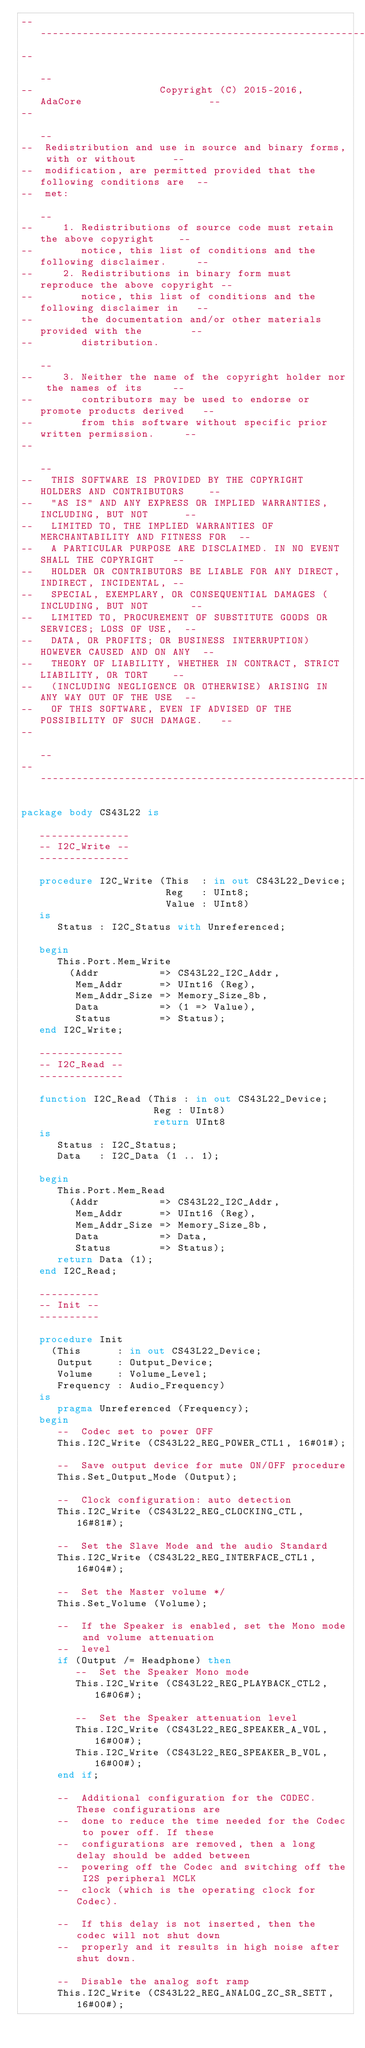<code> <loc_0><loc_0><loc_500><loc_500><_Ada_>------------------------------------------------------------------------------
--                                                                          --
--                     Copyright (C) 2015-2016, AdaCore                     --
--                                                                          --
--  Redistribution and use in source and binary forms, with or without      --
--  modification, are permitted provided that the following conditions are  --
--  met:                                                                    --
--     1. Redistributions of source code must retain the above copyright    --
--        notice, this list of conditions and the following disclaimer.     --
--     2. Redistributions in binary form must reproduce the above copyright --
--        notice, this list of conditions and the following disclaimer in   --
--        the documentation and/or other materials provided with the        --
--        distribution.                                                     --
--     3. Neither the name of the copyright holder nor the names of its     --
--        contributors may be used to endorse or promote products derived   --
--        from this software without specific prior written permission.     --
--                                                                          --
--   THIS SOFTWARE IS PROVIDED BY THE COPYRIGHT HOLDERS AND CONTRIBUTORS    --
--   "AS IS" AND ANY EXPRESS OR IMPLIED WARRANTIES, INCLUDING, BUT NOT      --
--   LIMITED TO, THE IMPLIED WARRANTIES OF MERCHANTABILITY AND FITNESS FOR  --
--   A PARTICULAR PURPOSE ARE DISCLAIMED. IN NO EVENT SHALL THE COPYRIGHT   --
--   HOLDER OR CONTRIBUTORS BE LIABLE FOR ANY DIRECT, INDIRECT, INCIDENTAL, --
--   SPECIAL, EXEMPLARY, OR CONSEQUENTIAL DAMAGES (INCLUDING, BUT NOT       --
--   LIMITED TO, PROCUREMENT OF SUBSTITUTE GOODS OR SERVICES; LOSS OF USE,  --
--   DATA, OR PROFITS; OR BUSINESS INTERRUPTION) HOWEVER CAUSED AND ON ANY  --
--   THEORY OF LIABILITY, WHETHER IN CONTRACT, STRICT LIABILITY, OR TORT    --
--   (INCLUDING NEGLIGENCE OR OTHERWISE) ARISING IN ANY WAY OUT OF THE USE  --
--   OF THIS SOFTWARE, EVEN IF ADVISED OF THE POSSIBILITY OF SUCH DAMAGE.   --
--                                                                          --
------------------------------------------------------------------------------

package body CS43L22 is

   ---------------
   -- I2C_Write --
   ---------------

   procedure I2C_Write (This  : in out CS43L22_Device;
                        Reg   : UInt8;
                        Value : UInt8)
   is
      Status : I2C_Status with Unreferenced;

   begin
      This.Port.Mem_Write
        (Addr          => CS43L22_I2C_Addr,
         Mem_Addr      => UInt16 (Reg),
         Mem_Addr_Size => Memory_Size_8b,
         Data          => (1 => Value),
         Status        => Status);
   end I2C_Write;

   --------------
   -- I2C_Read --
   --------------

   function I2C_Read (This : in out CS43L22_Device;
                      Reg : UInt8)
                      return UInt8
   is
      Status : I2C_Status;
      Data   : I2C_Data (1 .. 1);

   begin
      This.Port.Mem_Read
        (Addr          => CS43L22_I2C_Addr,
         Mem_Addr      => UInt16 (Reg),
         Mem_Addr_Size => Memory_Size_8b,
         Data          => Data,
         Status        => Status);
      return Data (1);
   end I2C_Read;

   ----------
   -- Init --
   ----------

   procedure Init
     (This      : in out CS43L22_Device;
      Output    : Output_Device;
      Volume    : Volume_Level;
      Frequency : Audio_Frequency)
   is
      pragma Unreferenced (Frequency);
   begin
      --  Codec set to power OFF
      This.I2C_Write (CS43L22_REG_POWER_CTL1, 16#01#);

      --  Save output device for mute ON/OFF procedure
      This.Set_Output_Mode (Output);

      --  Clock configuration: auto detection
      This.I2C_Write (CS43L22_REG_CLOCKING_CTL, 16#81#);

      --  Set the Slave Mode and the audio Standard
      This.I2C_Write (CS43L22_REG_INTERFACE_CTL1, 16#04#);

      --  Set the Master volume */
      This.Set_Volume (Volume);

      --  If the Speaker is enabled, set the Mono mode and volume attenuation
      --  level
      if (Output /= Headphone) then
         --  Set the Speaker Mono mode
         This.I2C_Write (CS43L22_REG_PLAYBACK_CTL2, 16#06#);

         --  Set the Speaker attenuation level
         This.I2C_Write (CS43L22_REG_SPEAKER_A_VOL, 16#00#);
         This.I2C_Write (CS43L22_REG_SPEAKER_B_VOL, 16#00#);
      end if;

      --  Additional configuration for the CODEC. These configurations are
      --  done to reduce the time needed for the Codec to power off. If these
      --  configurations are removed, then a long delay should be added between
      --  powering off the Codec and switching off the I2S peripheral MCLK
      --  clock (which is the operating clock for Codec).

      --  If this delay is not inserted, then the codec will not shut down
      --  properly and it results in high noise after shut down.

      --  Disable the analog soft ramp
      This.I2C_Write (CS43L22_REG_ANALOG_ZC_SR_SETT, 16#00#);</code> 